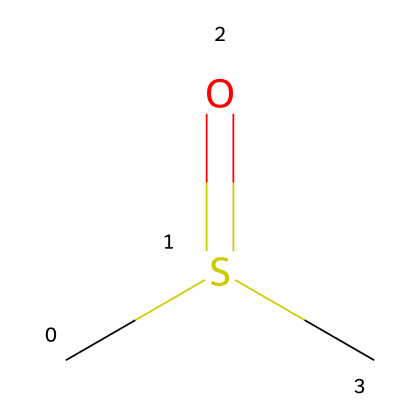What is the molecular formula of DMSO? The SMILES representation "CS(=O)C" indicates the presence of two carbon atoms (C), one sulfur atom (S), and one oxygen atom (O), leading to the molecular formula C2H6OS.
Answer: C2H6OS How many hydrogen atoms are there in DMSO? Analyzing the SMILES "CS(=O)C", we find there are six hydrogen atoms attached to the two carbon atoms, confirming the number of hydrogen atoms in the molecular structure is six.
Answer: 6 What type of functional group is present in DMSO? The "S(=O)" part of the SMILES shows the presence of a sulfoxide functional group, where sulfur is double bonded to an oxygen atom, indicating that DMSO contains a sulfoxide functional group.
Answer: sulfoxide What is the hybridization of the sulfur atom in DMSO? In the structure "CS(=O)C", the sulfur atom is bonded to two carbon atoms (single bonds) and one oxygen atom (double bond), which results in a hybridization state of sp2 for the sulfur atom.
Answer: sp2 How many total bonds are there in DMSO? The chemical structure "CS(=O)C" features two carbon-sulfur single bonds, one double bond between sulfur and oxygen, and one additional carbon-to-carbon bond, leading to a total of five bonds overall.
Answer: 5 Is DMSO a polar or nonpolar solvent? Given its structure, where the sulfoxide functional group has a significant dipole moment due to the electronegativity difference between sulfur and oxygen, DMSO is classified as a polar solvent.
Answer: polar What can DMSO be used for in the medical field? DMSO is recognized as a solvent for pharmaceutical compounds, known for its ability to penetrate biological membranes, making it useful in drug formulations and topical therapies.
Answer: drug solvent 